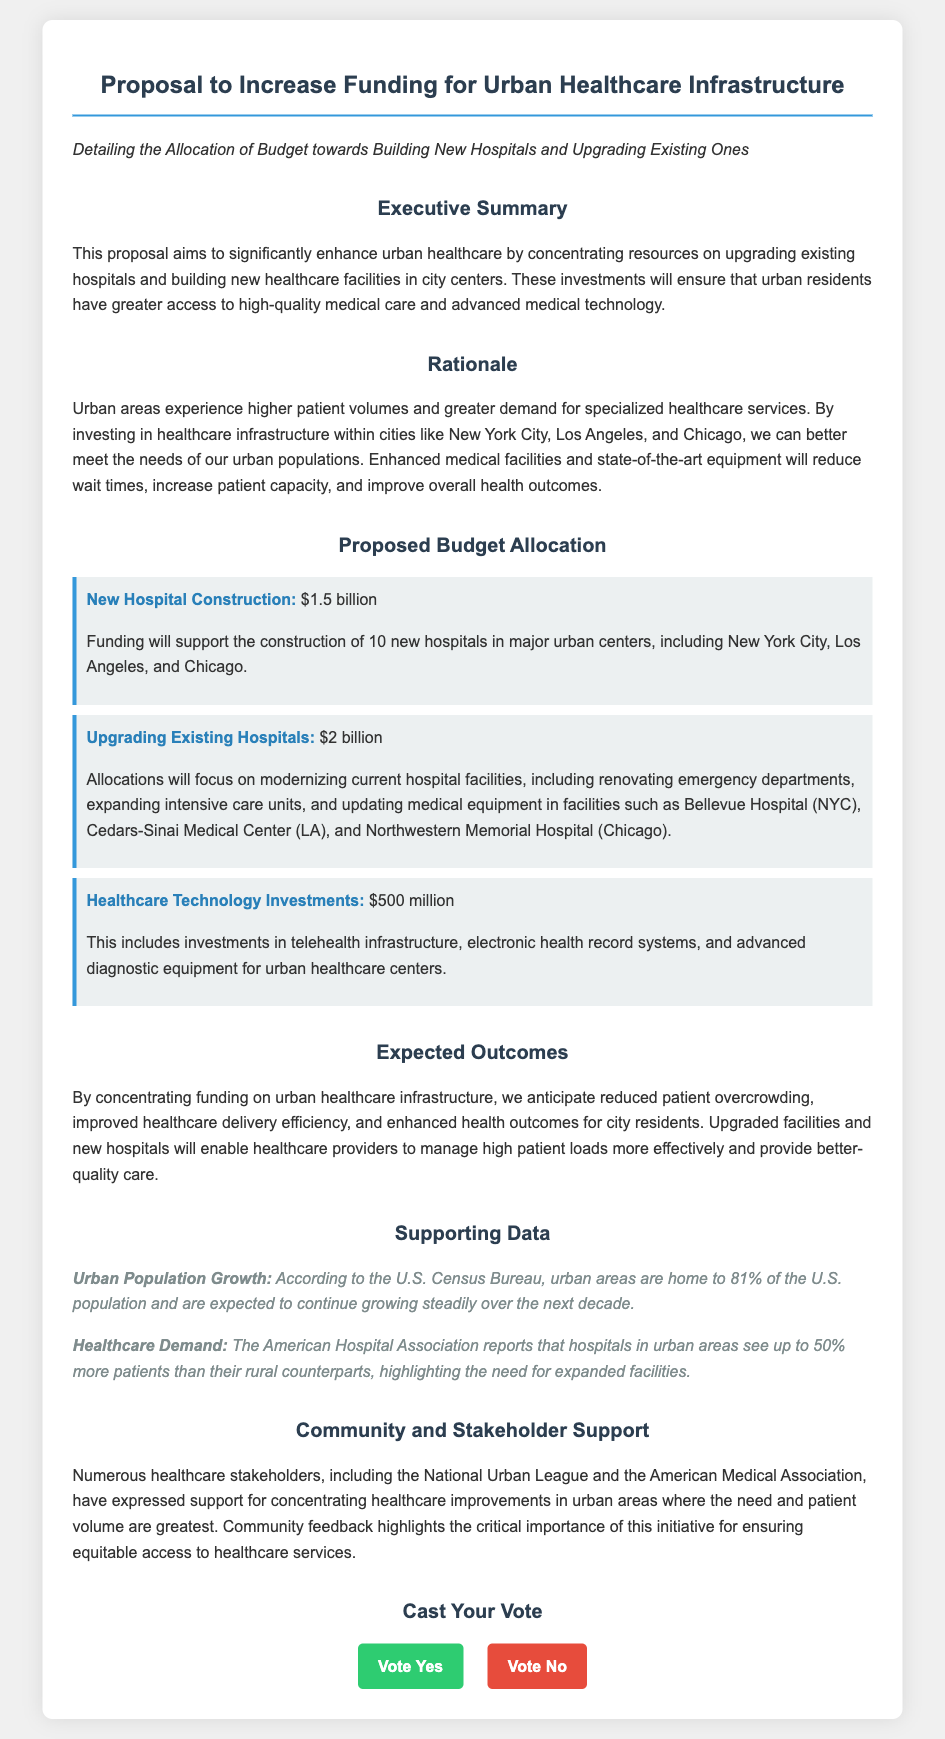what is the budget for new hospital construction? The budget for new hospital construction is specified in the document as $1.5 billion.
Answer: $1.5 billion how many new hospitals are proposed to be built? The document states that 10 new hospitals are proposed to be constructed in major urban centers.
Answer: 10 what is the total funding allocated for upgrading existing hospitals? The total funding allocated for upgrading existing hospitals is detailed as $2 billion in the document.
Answer: $2 billion what percentage of the U.S. population lives in urban areas? According to the document, the U.S. Census Bureau reports that 81% of the U.S. population lives in urban areas.
Answer: 81% which hospital in New York City is mentioned for upgrades? Bellevue Hospital is mentioned in the document as one of the hospitals for upgrades.
Answer: Bellevue Hospital what is the primary objective of the proposal? The primary objective is to enhance urban healthcare by concentrating resources on upgrading existing hospitals and building new ones.
Answer: Enhance urban healthcare who expressed support for the initiative? The document states that the National Urban League and the American Medical Association expressed support for the initiative.
Answer: National Urban League and the American Medical Association how much is allocated for healthcare technology investments? The document specifies that $500 million is allocated for healthcare technology investments.
Answer: $500 million what is one expected outcome of the funding proposal? One expected outcome is reduced patient overcrowding as a result of the proposed funding.
Answer: Reduced patient overcrowding 